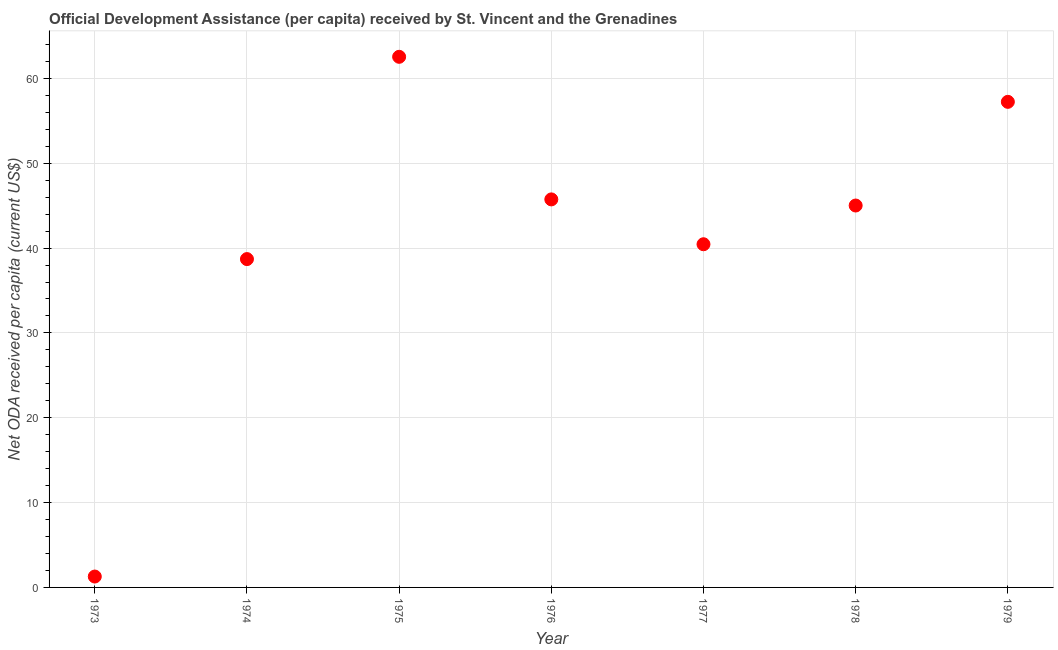What is the net oda received per capita in 1977?
Give a very brief answer. 40.45. Across all years, what is the maximum net oda received per capita?
Offer a terse response. 62.54. Across all years, what is the minimum net oda received per capita?
Make the answer very short. 1.28. In which year was the net oda received per capita maximum?
Give a very brief answer. 1975. What is the sum of the net oda received per capita?
Give a very brief answer. 290.97. What is the difference between the net oda received per capita in 1977 and 1979?
Keep it short and to the point. -16.78. What is the average net oda received per capita per year?
Your response must be concise. 41.57. What is the median net oda received per capita?
Provide a succinct answer. 45.01. What is the ratio of the net oda received per capita in 1975 to that in 1978?
Your answer should be very brief. 1.39. What is the difference between the highest and the second highest net oda received per capita?
Give a very brief answer. 5.31. Is the sum of the net oda received per capita in 1973 and 1978 greater than the maximum net oda received per capita across all years?
Keep it short and to the point. No. What is the difference between the highest and the lowest net oda received per capita?
Give a very brief answer. 61.26. In how many years, is the net oda received per capita greater than the average net oda received per capita taken over all years?
Ensure brevity in your answer.  4. How many dotlines are there?
Give a very brief answer. 1. What is the difference between two consecutive major ticks on the Y-axis?
Offer a very short reply. 10. Does the graph contain any zero values?
Your answer should be compact. No. Does the graph contain grids?
Offer a terse response. Yes. What is the title of the graph?
Offer a terse response. Official Development Assistance (per capita) received by St. Vincent and the Grenadines. What is the label or title of the X-axis?
Offer a very short reply. Year. What is the label or title of the Y-axis?
Offer a very short reply. Net ODA received per capita (current US$). What is the Net ODA received per capita (current US$) in 1973?
Offer a terse response. 1.28. What is the Net ODA received per capita (current US$) in 1974?
Provide a succinct answer. 38.7. What is the Net ODA received per capita (current US$) in 1975?
Your answer should be compact. 62.54. What is the Net ODA received per capita (current US$) in 1976?
Your answer should be very brief. 45.74. What is the Net ODA received per capita (current US$) in 1977?
Your answer should be compact. 40.45. What is the Net ODA received per capita (current US$) in 1978?
Provide a succinct answer. 45.01. What is the Net ODA received per capita (current US$) in 1979?
Make the answer very short. 57.24. What is the difference between the Net ODA received per capita (current US$) in 1973 and 1974?
Your response must be concise. -37.42. What is the difference between the Net ODA received per capita (current US$) in 1973 and 1975?
Offer a terse response. -61.26. What is the difference between the Net ODA received per capita (current US$) in 1973 and 1976?
Your answer should be compact. -44.45. What is the difference between the Net ODA received per capita (current US$) in 1973 and 1977?
Give a very brief answer. -39.17. What is the difference between the Net ODA received per capita (current US$) in 1973 and 1978?
Your answer should be compact. -43.73. What is the difference between the Net ODA received per capita (current US$) in 1973 and 1979?
Offer a very short reply. -55.95. What is the difference between the Net ODA received per capita (current US$) in 1974 and 1975?
Your response must be concise. -23.84. What is the difference between the Net ODA received per capita (current US$) in 1974 and 1976?
Offer a terse response. -7.04. What is the difference between the Net ODA received per capita (current US$) in 1974 and 1977?
Offer a terse response. -1.75. What is the difference between the Net ODA received per capita (current US$) in 1974 and 1978?
Provide a succinct answer. -6.31. What is the difference between the Net ODA received per capita (current US$) in 1974 and 1979?
Keep it short and to the point. -18.53. What is the difference between the Net ODA received per capita (current US$) in 1975 and 1976?
Your response must be concise. 16.81. What is the difference between the Net ODA received per capita (current US$) in 1975 and 1977?
Ensure brevity in your answer.  22.09. What is the difference between the Net ODA received per capita (current US$) in 1975 and 1978?
Offer a terse response. 17.53. What is the difference between the Net ODA received per capita (current US$) in 1975 and 1979?
Make the answer very short. 5.31. What is the difference between the Net ODA received per capita (current US$) in 1976 and 1977?
Give a very brief answer. 5.29. What is the difference between the Net ODA received per capita (current US$) in 1976 and 1978?
Give a very brief answer. 0.72. What is the difference between the Net ODA received per capita (current US$) in 1976 and 1979?
Give a very brief answer. -11.5. What is the difference between the Net ODA received per capita (current US$) in 1977 and 1978?
Provide a short and direct response. -4.56. What is the difference between the Net ODA received per capita (current US$) in 1977 and 1979?
Provide a succinct answer. -16.78. What is the difference between the Net ODA received per capita (current US$) in 1978 and 1979?
Your answer should be very brief. -12.22. What is the ratio of the Net ODA received per capita (current US$) in 1973 to that in 1974?
Offer a terse response. 0.03. What is the ratio of the Net ODA received per capita (current US$) in 1973 to that in 1975?
Make the answer very short. 0.02. What is the ratio of the Net ODA received per capita (current US$) in 1973 to that in 1976?
Your response must be concise. 0.03. What is the ratio of the Net ODA received per capita (current US$) in 1973 to that in 1977?
Your answer should be very brief. 0.03. What is the ratio of the Net ODA received per capita (current US$) in 1973 to that in 1978?
Your answer should be compact. 0.03. What is the ratio of the Net ODA received per capita (current US$) in 1973 to that in 1979?
Your response must be concise. 0.02. What is the ratio of the Net ODA received per capita (current US$) in 1974 to that in 1975?
Offer a terse response. 0.62. What is the ratio of the Net ODA received per capita (current US$) in 1974 to that in 1976?
Make the answer very short. 0.85. What is the ratio of the Net ODA received per capita (current US$) in 1974 to that in 1977?
Your answer should be very brief. 0.96. What is the ratio of the Net ODA received per capita (current US$) in 1974 to that in 1978?
Your answer should be very brief. 0.86. What is the ratio of the Net ODA received per capita (current US$) in 1974 to that in 1979?
Your response must be concise. 0.68. What is the ratio of the Net ODA received per capita (current US$) in 1975 to that in 1976?
Ensure brevity in your answer.  1.37. What is the ratio of the Net ODA received per capita (current US$) in 1975 to that in 1977?
Keep it short and to the point. 1.55. What is the ratio of the Net ODA received per capita (current US$) in 1975 to that in 1978?
Ensure brevity in your answer.  1.39. What is the ratio of the Net ODA received per capita (current US$) in 1975 to that in 1979?
Offer a terse response. 1.09. What is the ratio of the Net ODA received per capita (current US$) in 1976 to that in 1977?
Offer a terse response. 1.13. What is the ratio of the Net ODA received per capita (current US$) in 1976 to that in 1979?
Provide a short and direct response. 0.8. What is the ratio of the Net ODA received per capita (current US$) in 1977 to that in 1978?
Your answer should be compact. 0.9. What is the ratio of the Net ODA received per capita (current US$) in 1977 to that in 1979?
Your answer should be compact. 0.71. What is the ratio of the Net ODA received per capita (current US$) in 1978 to that in 1979?
Offer a very short reply. 0.79. 